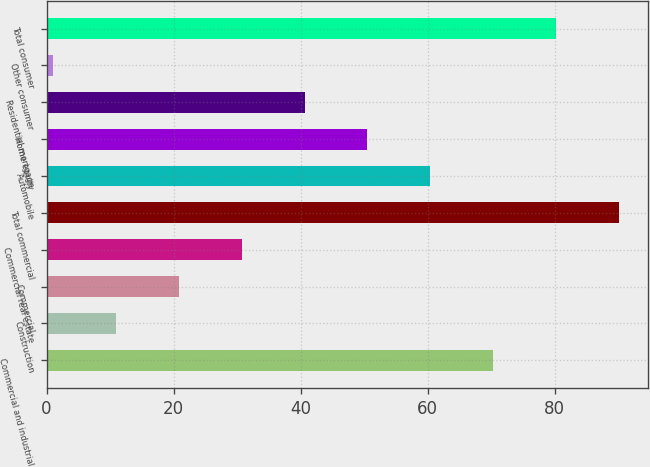Convert chart to OTSL. <chart><loc_0><loc_0><loc_500><loc_500><bar_chart><fcel>Commercial and industrial<fcel>Construction<fcel>Commercial<fcel>Commercial real estate<fcel>Total commercial<fcel>Automobile<fcel>Home equity<fcel>Residential mortgage<fcel>Other consumer<fcel>Total consumer<nl><fcel>70.3<fcel>10.9<fcel>20.8<fcel>30.7<fcel>90.1<fcel>60.4<fcel>50.5<fcel>40.6<fcel>1<fcel>80.2<nl></chart> 